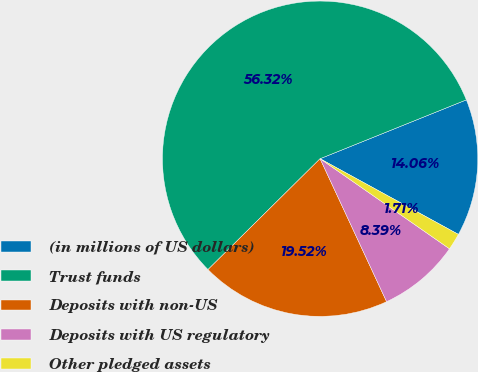<chart> <loc_0><loc_0><loc_500><loc_500><pie_chart><fcel>(in millions of US dollars)<fcel>Trust funds<fcel>Deposits with non-US<fcel>Deposits with US regulatory<fcel>Other pledged assets<nl><fcel>14.06%<fcel>56.32%<fcel>19.52%<fcel>8.39%<fcel>1.71%<nl></chart> 